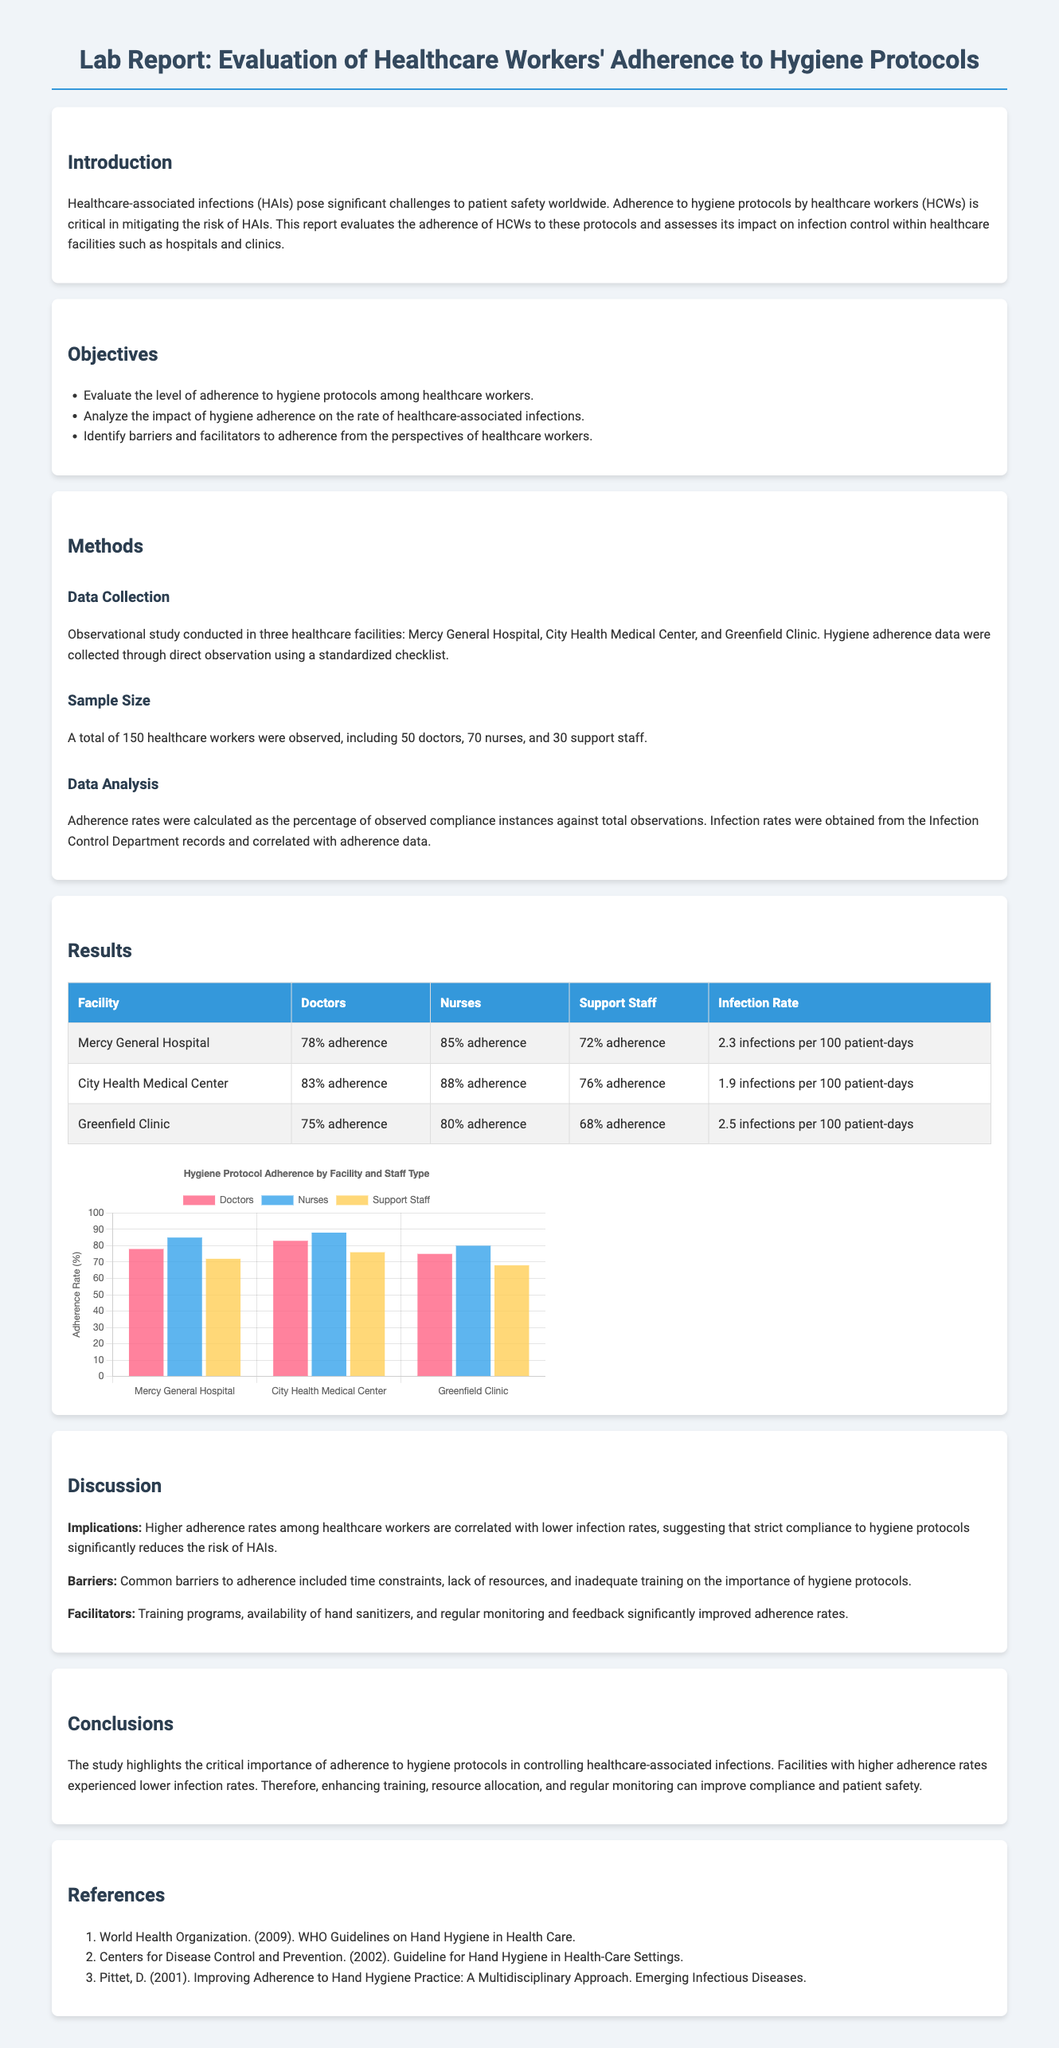What are healthcare-associated infections? The document defines healthcare-associated infections as significant challenges to patient safety worldwide, emphasizing their impact on public health.
Answer: Healthcare-associated infections What was the sample size of observed healthcare workers? The sample size is explicitly mentioned in the Methods section of the document, indicating the total number of healthcare workers observed.
Answer: 150 What is the infection rate at City Health Medical Center? The infection rate is provided in the Results section as part of the data for each facility, specifying the rate for City Health Medical Center.
Answer: 1.9 infections per 100 patient-days Which staff type had the highest adherence rate at Mercy General Hospital? The adherence rates for doctors, nurses, and support staff at Mercy General Hospital are presented in the Results section.
Answer: Nurses What were the common barriers to adherence mentioned in the discussion? The document states that common barriers to adherence included time constraints and lack of resources, highlighting the challenges faced by healthcare workers.
Answer: Time constraints, lack of resources What is one implication of higher adherence rates mentioned in the report? Implications of higher adherence rates are discussed, specifically relating to the association with infection rates, indicating its significance for infection control.
Answer: Lower infection rates What type of study was conducted for this evaluation? The type of study is categorized in the document, indicating how the data was collected and analyzed over the observed healthcare workers.
Answer: Observational study What improvement facilitated higher adherence rates according to the findings? The document highlights specific facilitators to adherence, including training programs and regular monitoring, indicating key areas for improvement.
Answer: Training programs 